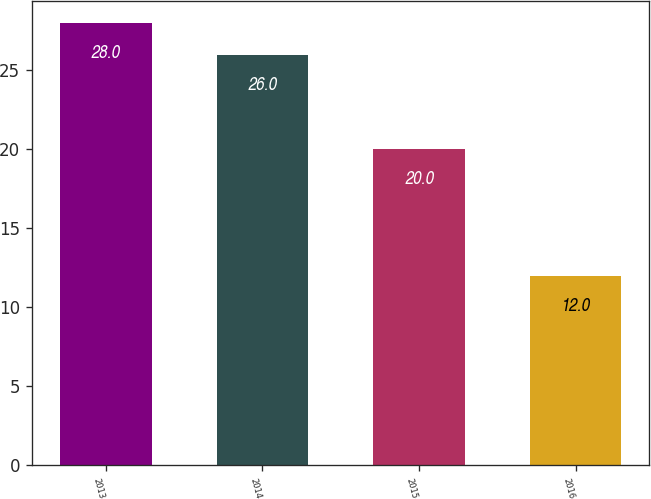Convert chart to OTSL. <chart><loc_0><loc_0><loc_500><loc_500><bar_chart><fcel>2013<fcel>2014<fcel>2015<fcel>2016<nl><fcel>28<fcel>26<fcel>20<fcel>12<nl></chart> 